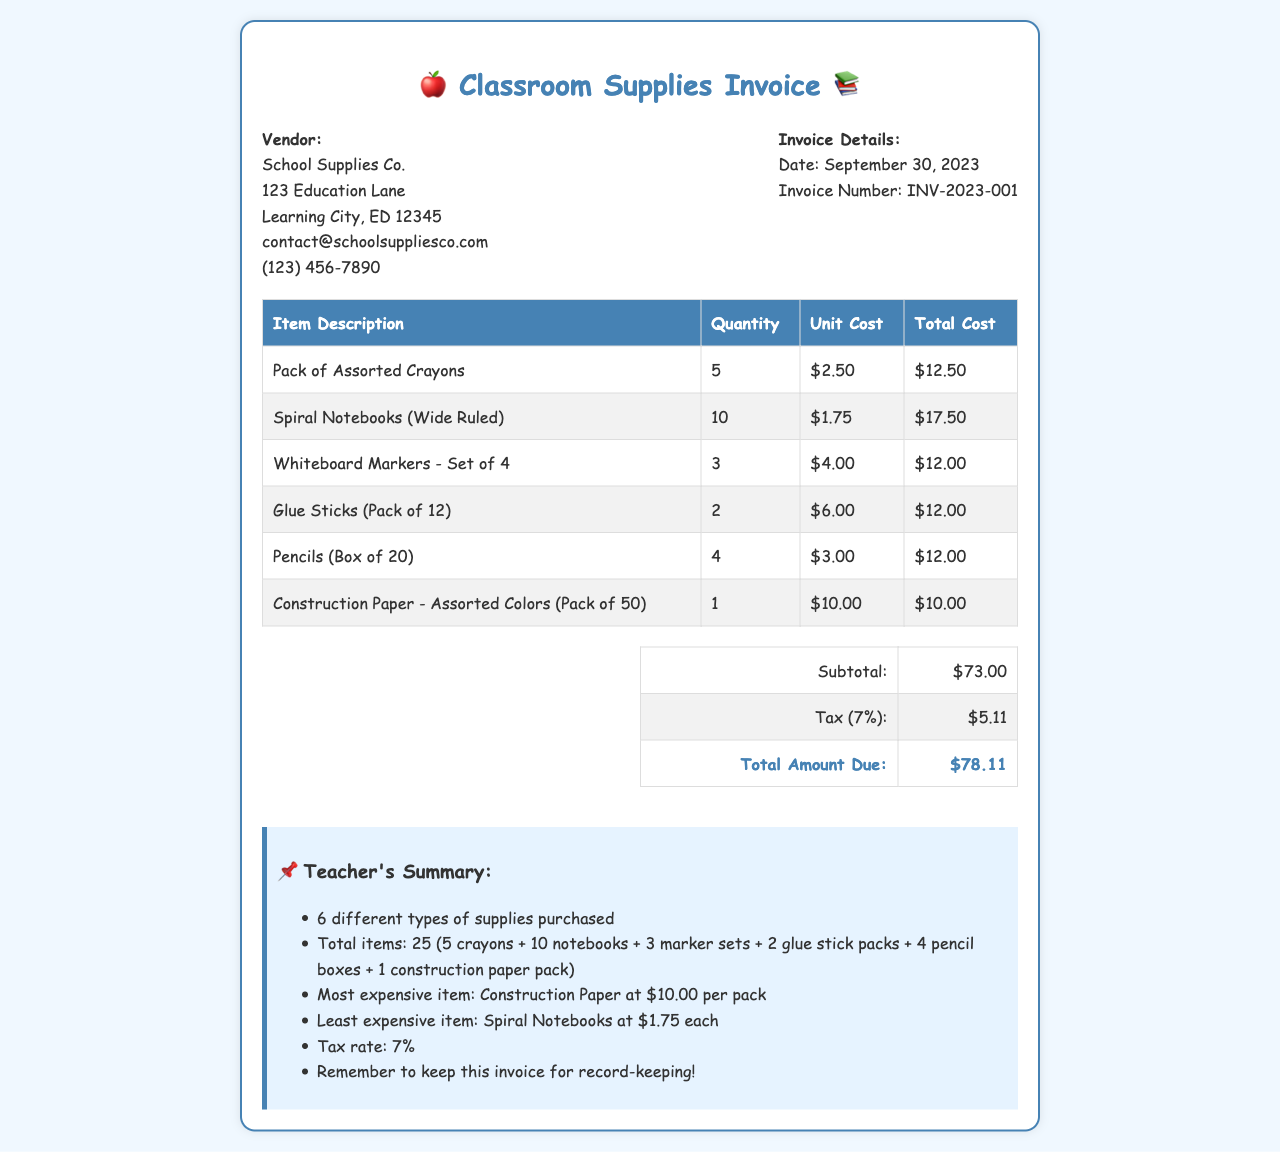What is the invoice date? The invoice date is listed in the document under the invoice details section.
Answer: September 30, 2023 Who is the vendor? The vendor's name is provided at the top of the document.
Answer: School Supplies Co What is the total amount due? The total amount due is summarized in the summary table at the end of the document.
Answer: $78.11 How many spiral notebooks were purchased? The quantity of spiral notebooks is specified in the itemized list of the invoice.
Answer: 10 What is the most expensive item? The most expensive item's description and cost can be found in the itemized list.
Answer: Construction Paper What percentage is the tax applied? The tax percentage is mentioned in the summary section of the invoice.
Answer: 7% How many different types of supplies were purchased? The number of different supplies is summarized in the teacher's summary section.
Answer: 6 What is the subtotal before tax? The subtotal is clearly stated in the summary table of the invoice document.
Answer: $73.00 What is the unit cost of the glue sticks? The unit cost for the glue sticks is listed in the itemized table.
Answer: $6.00 